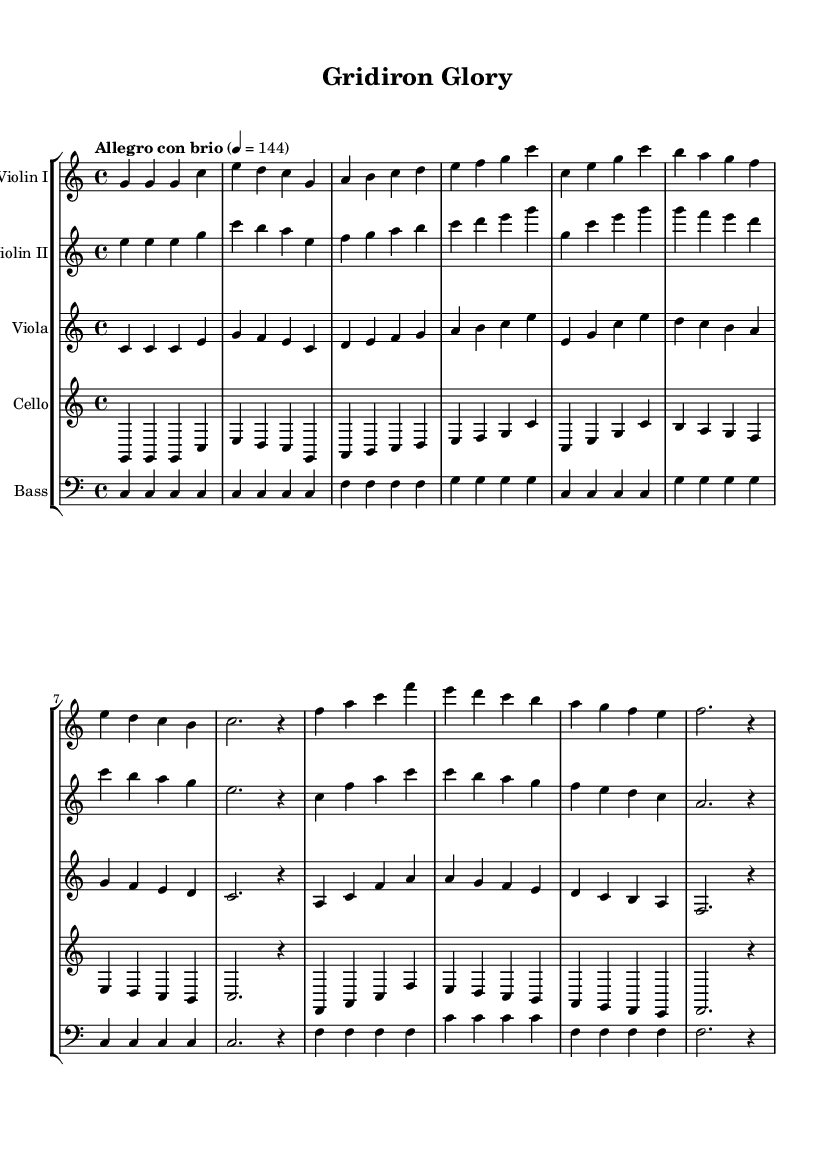What is the key signature of this music? The key signature is indicated at the beginning of the staff, showing no sharps or flats, which defines it as C major.
Answer: C major What is the time signature of this music? The time signature is written at the beginning of the music as a fraction, displaying 4 over 4, which means there are four beats per measure.
Answer: 4/4 What is the tempo marking of this music? The tempo marking is typically written above the staff, and in this case, it denotes "Allegro con brio" at a speed of 144 beats per minute.
Answer: Allegro con brio How many instruments are in this symphony? The notation includes five distinct staves, each representing different instruments, specifically two violins, a viola, a cello, and a bass.
Answer: Five Which instrument plays the highest notes? By observing the staves, we can see that the first violin is typically written in a higher pitch range compared to the other instruments, indicating it plays the highest notes.
Answer: Violin I Which section has the longest note value? When analyzing the rhythmic values throughout the sheet music, the longest note is a whole note (or 2 dotted half notes) represented for various instruments in resting measures, defining the quiet moments in the music.
Answer: Whole note What thematic element do you notice in the dynamics of this symphony? By reviewing the dynamics shown in the score, there are markings referring to crescendos and a vigorous tempo, indicating an intense and passionate drive throughout the championship themes.
Answer: Intensity 